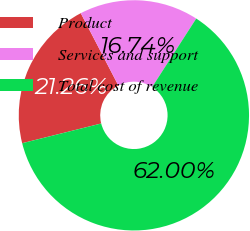<chart> <loc_0><loc_0><loc_500><loc_500><pie_chart><fcel>Product<fcel>Services and support<fcel>Total cost of revenue<nl><fcel>21.26%<fcel>16.74%<fcel>62.0%<nl></chart> 